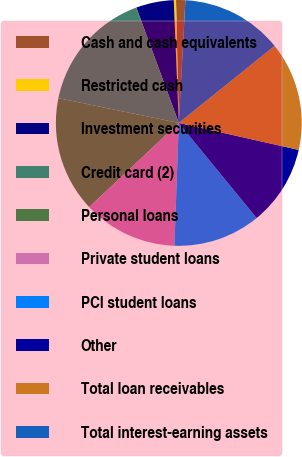Convert chart. <chart><loc_0><loc_0><loc_500><loc_500><pie_chart><fcel>Cash and cash equivalents<fcel>Restricted cash<fcel>Investment securities<fcel>Credit card (2)<fcel>Personal loans<fcel>Private student loans<fcel>PCI student loans<fcel>Other<fcel>Total loan receivables<fcel>Total interest-earning assets<nl><fcel>1.22%<fcel>0.29%<fcel>4.96%<fcel>16.16%<fcel>15.23%<fcel>12.43%<fcel>11.49%<fcel>10.56%<fcel>14.3%<fcel>13.36%<nl></chart> 